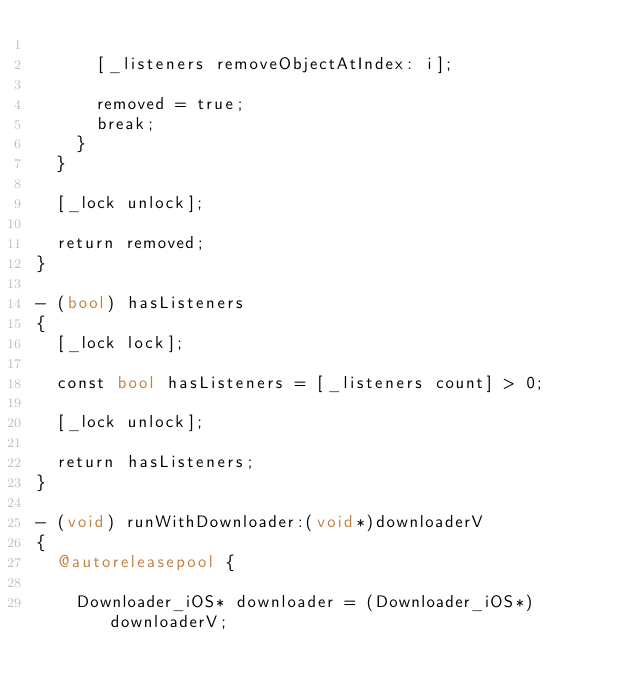Convert code to text. <code><loc_0><loc_0><loc_500><loc_500><_ObjectiveC_>
      [_listeners removeObjectAtIndex: i];

      removed = true;
      break;
    }
  }

  [_lock unlock];

  return removed;
}

- (bool) hasListeners
{
  [_lock lock];

  const bool hasListeners = [_listeners count] > 0;

  [_lock unlock];

  return hasListeners;
}

- (void) runWithDownloader:(void*)downloaderV
{
  @autoreleasepool {

    Downloader_iOS* downloader = (Downloader_iOS*) downloaderV;</code> 